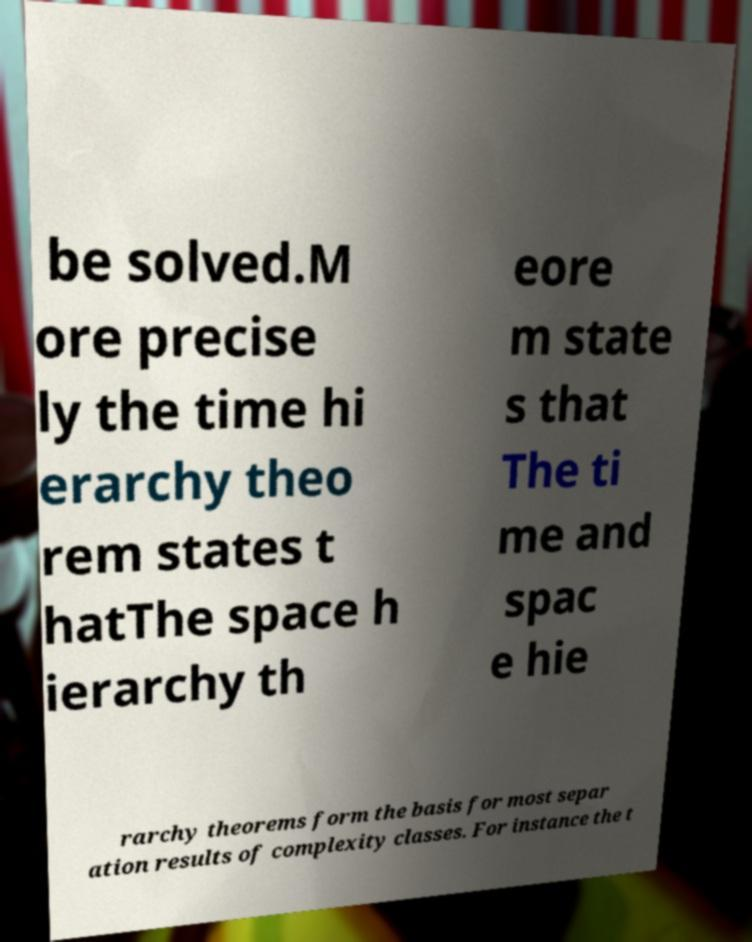What messages or text are displayed in this image? I need them in a readable, typed format. be solved.M ore precise ly the time hi erarchy theo rem states t hatThe space h ierarchy th eore m state s that The ti me and spac e hie rarchy theorems form the basis for most separ ation results of complexity classes. For instance the t 